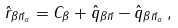Convert formula to latex. <formula><loc_0><loc_0><loc_500><loc_500>\hat { r } _ { \beta \vec { n } _ { \alpha } } = C _ { \beta } + \hat { q } _ { \beta \vec { n } } - \hat { q } _ { \beta \vec { n } _ { \alpha } } \, ,</formula> 